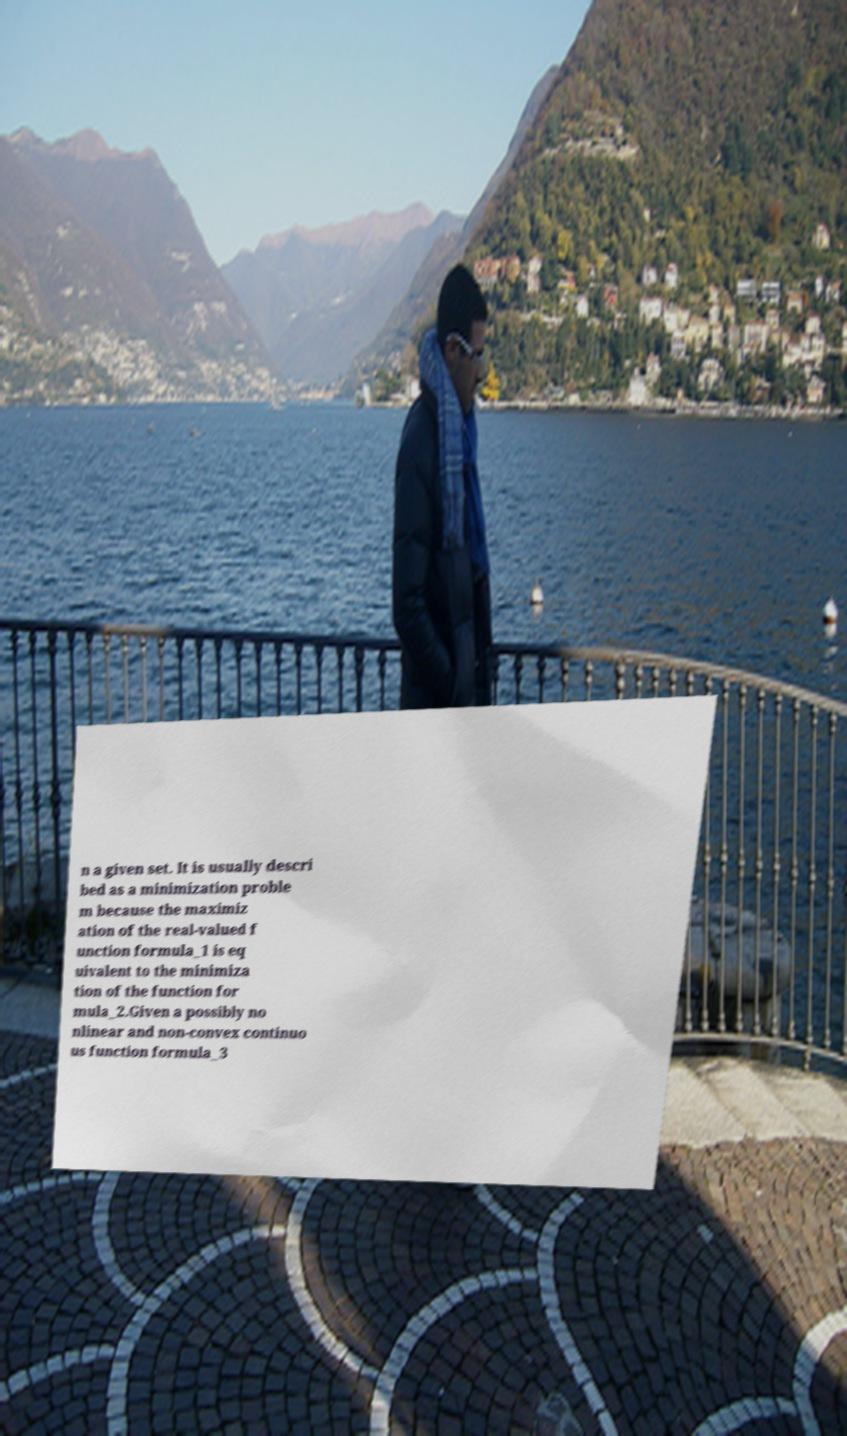Please identify and transcribe the text found in this image. n a given set. It is usually descri bed as a minimization proble m because the maximiz ation of the real-valued f unction formula_1 is eq uivalent to the minimiza tion of the function for mula_2.Given a possibly no nlinear and non-convex continuo us function formula_3 